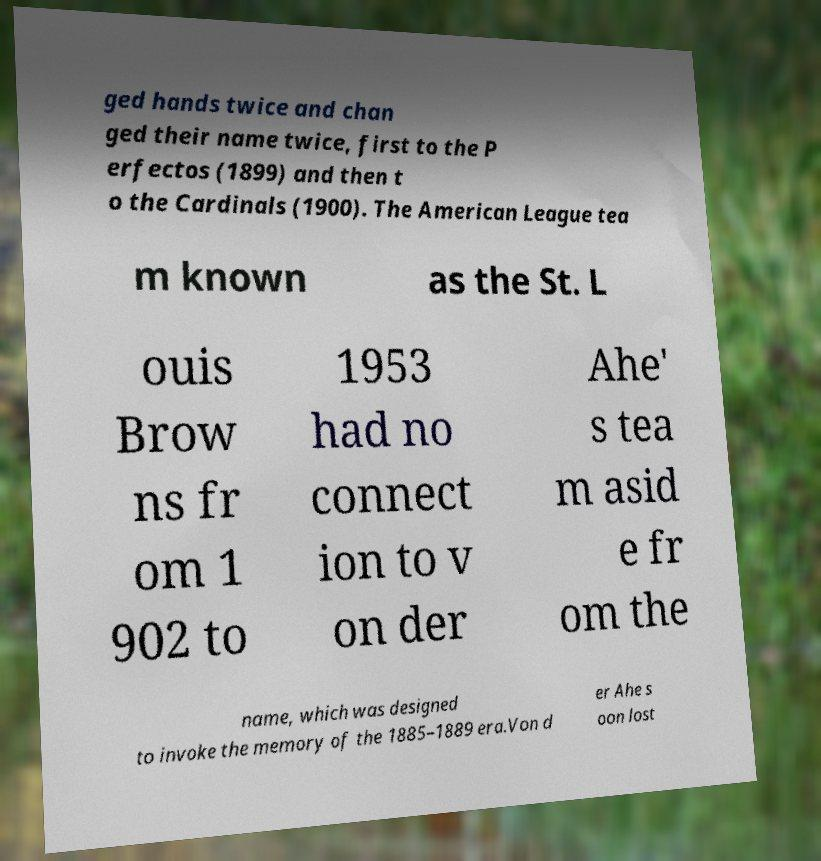Can you read and provide the text displayed in the image?This photo seems to have some interesting text. Can you extract and type it out for me? ged hands twice and chan ged their name twice, first to the P erfectos (1899) and then t o the Cardinals (1900). The American League tea m known as the St. L ouis Brow ns fr om 1 902 to 1953 had no connect ion to v on der Ahe' s tea m asid e fr om the name, which was designed to invoke the memory of the 1885–1889 era.Von d er Ahe s oon lost 